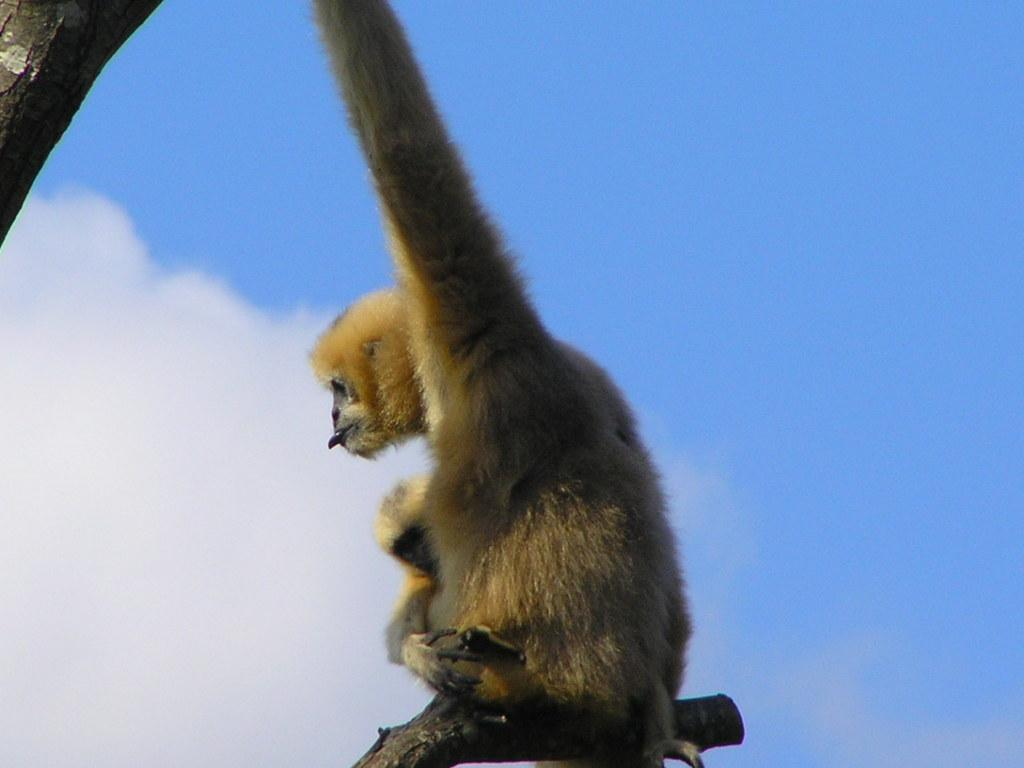What is the main subject in the center of the image? There is a monkey in the center of the image. What objects can be seen in the image besides the monkey? There are wooden sticks visible in the image. What is visible at the top of the image? The sky is visible at the top of the image. What type of fork is the monkey using to play with the wooden sticks in the image? There is no fork present in the image, and the monkey is not shown playing with the wooden sticks. 